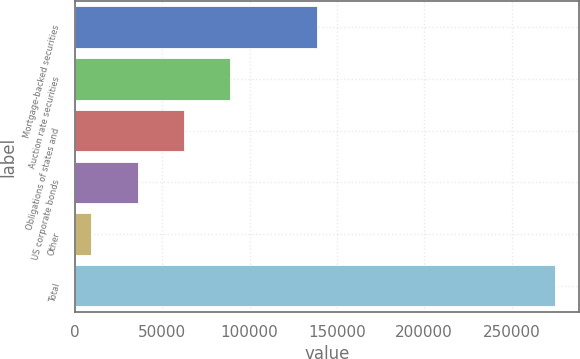<chart> <loc_0><loc_0><loc_500><loc_500><bar_chart><fcel>Mortgage-backed securities<fcel>Auction rate securities<fcel>Obligations of states and<fcel>US corporate bonds<fcel>Other<fcel>Total<nl><fcel>138898<fcel>89028.9<fcel>62476.6<fcel>35924.3<fcel>9372<fcel>274895<nl></chart> 